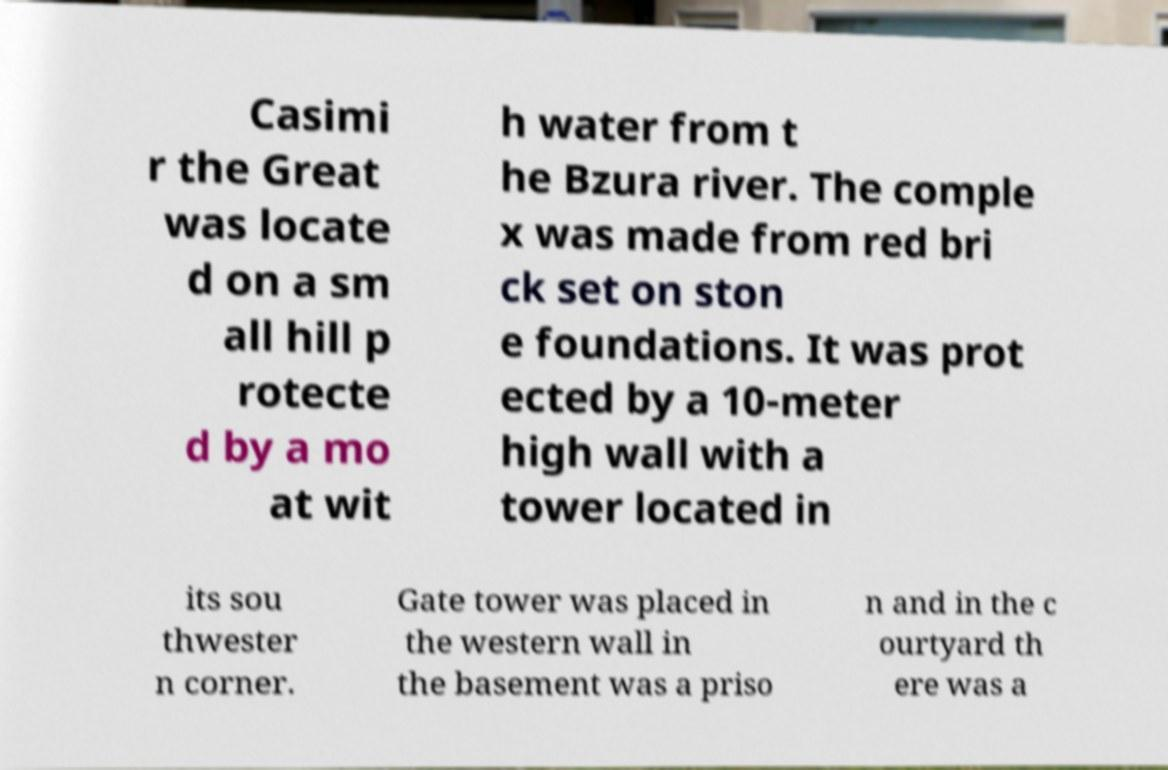Can you read and provide the text displayed in the image?This photo seems to have some interesting text. Can you extract and type it out for me? Casimi r the Great was locate d on a sm all hill p rotecte d by a mo at wit h water from t he Bzura river. The comple x was made from red bri ck set on ston e foundations. It was prot ected by a 10-meter high wall with a tower located in its sou thwester n corner. Gate tower was placed in the western wall in the basement was a priso n and in the c ourtyard th ere was a 